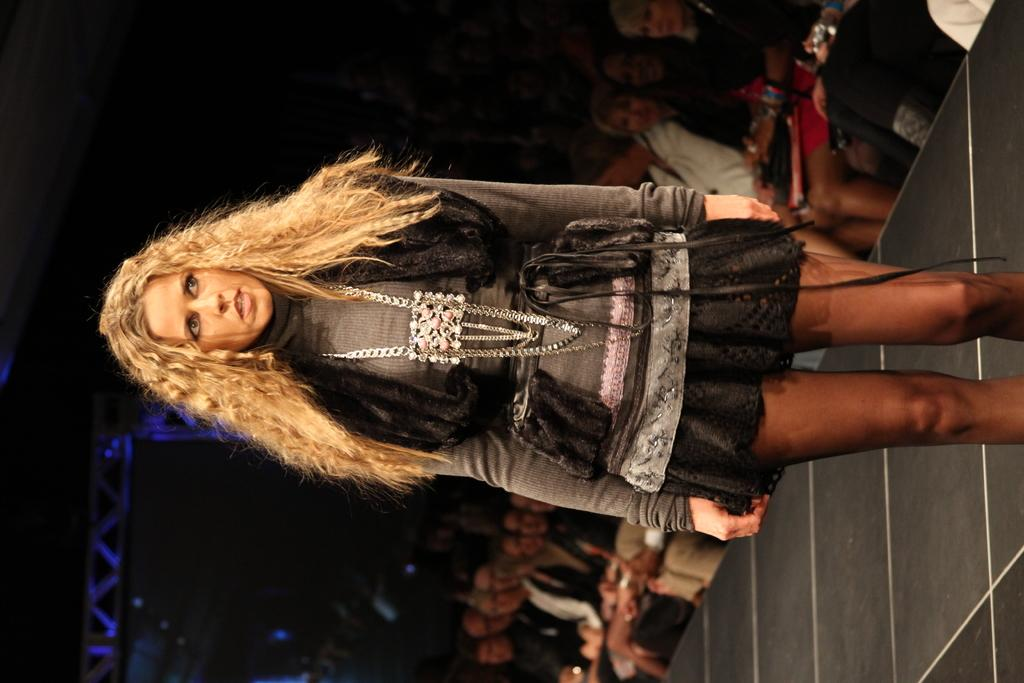What is the person in the image doing? The person is standing on the floor in the image. What can be seen in the background of the image? There are iron grills in the background of the image. Are there any other people visible in the image? Yes, there is at least one person sitting on a chair in the background of the image. What type of glass is being used to create a light show in the image? There is no glass or light show present in the image. 